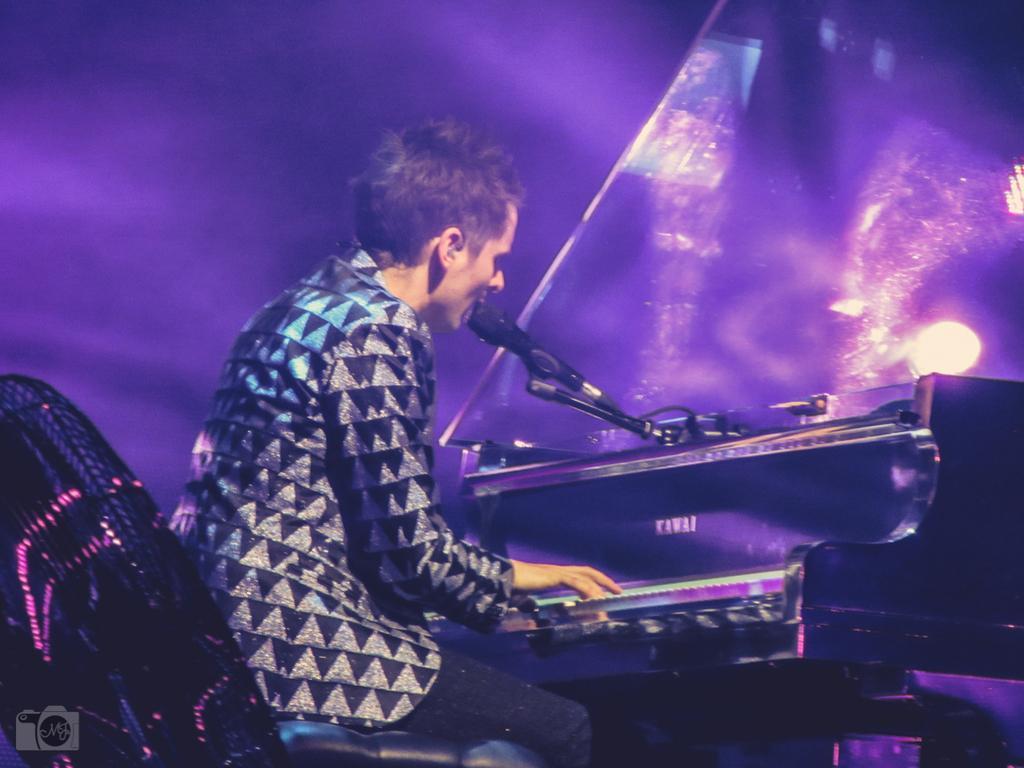In one or two sentences, can you explain what this image depicts? In the image there is a man with black dress is sitting. In front of him there is a piano and in front of his mouth there is a mic. And there is a violet background. 